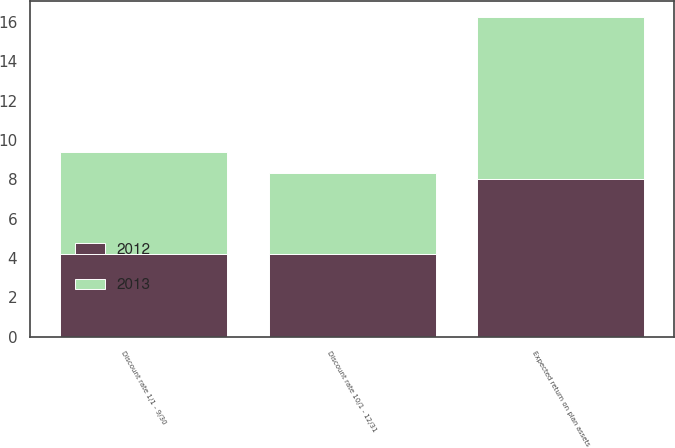Convert chart. <chart><loc_0><loc_0><loc_500><loc_500><stacked_bar_chart><ecel><fcel>Discount rate 1/1 - 9/30<fcel>Discount rate 10/1 - 12/31<fcel>Expected return on plan assets<nl><fcel>2012<fcel>4.2<fcel>4.2<fcel>8<nl><fcel>2013<fcel>5.2<fcel>4.1<fcel>8.25<nl></chart> 